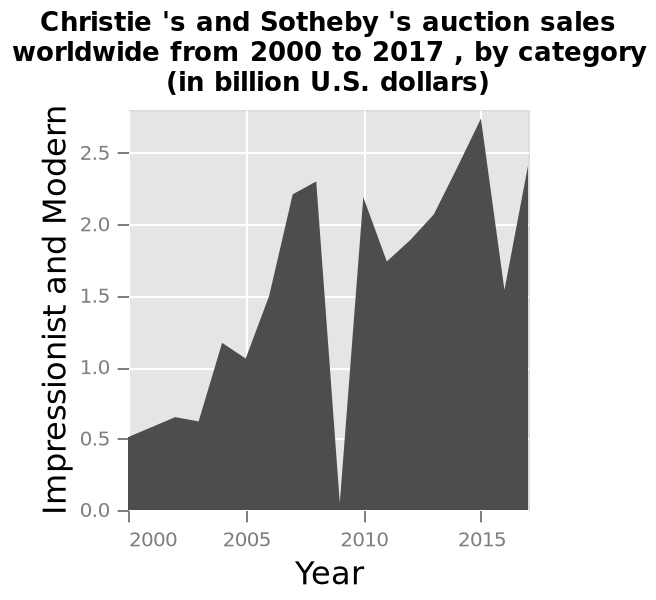<image>
What does the y-axis represent on the graph? The y-axis represents the sales in billion U.S. dollars, specifically for the category of Impressionist and Modern, on a linear scale from 0.0 to 2.5. When did a significant decrease occur?  A significant decrease occurred in 2007. Does the y-axis represent the sales in trillion U.S. dollars, specifically for the category of Impressionist and Modern, on a logarithmic scale from 10.0 to 20.0? No.The y-axis represents the sales in billion U.S. dollars, specifically for the category of Impressionist and Modern, on a linear scale from 0.0 to 2.5. 